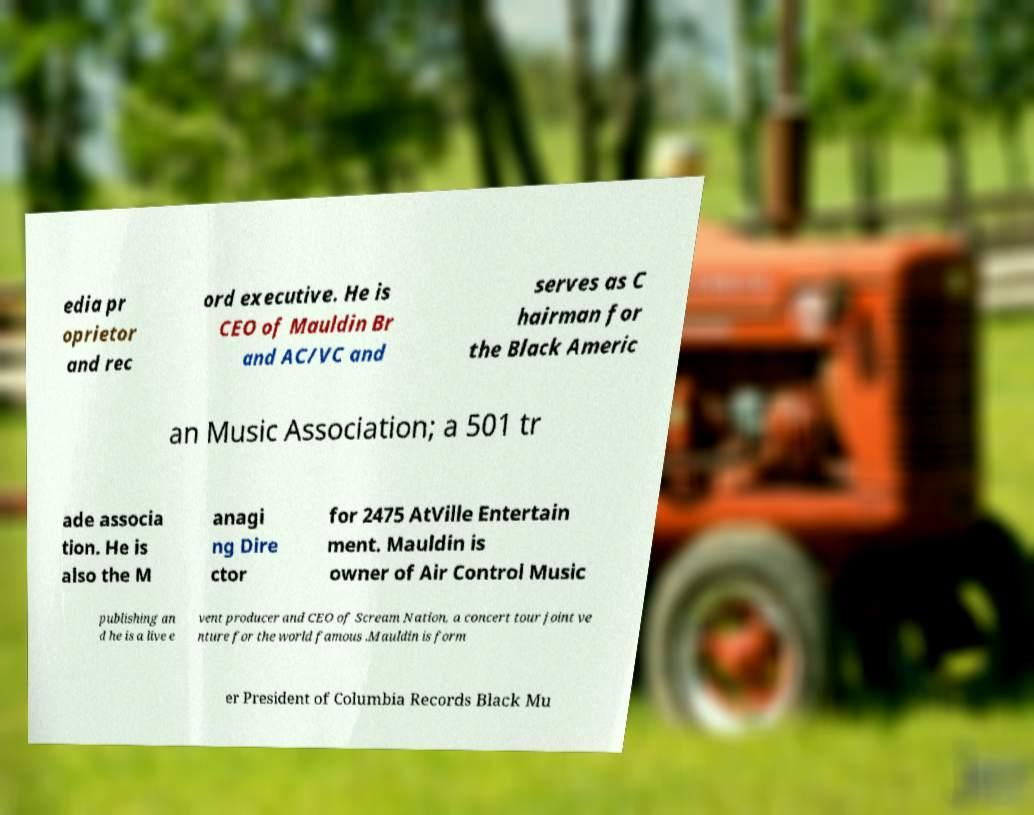For documentation purposes, I need the text within this image transcribed. Could you provide that? edia pr oprietor and rec ord executive. He is CEO of Mauldin Br and AC/VC and serves as C hairman for the Black Americ an Music Association; a 501 tr ade associa tion. He is also the M anagi ng Dire ctor for 2475 AtVille Entertain ment. Mauldin is owner of Air Control Music publishing an d he is a live e vent producer and CEO of Scream Nation, a concert tour joint ve nture for the world famous .Mauldin is form er President of Columbia Records Black Mu 